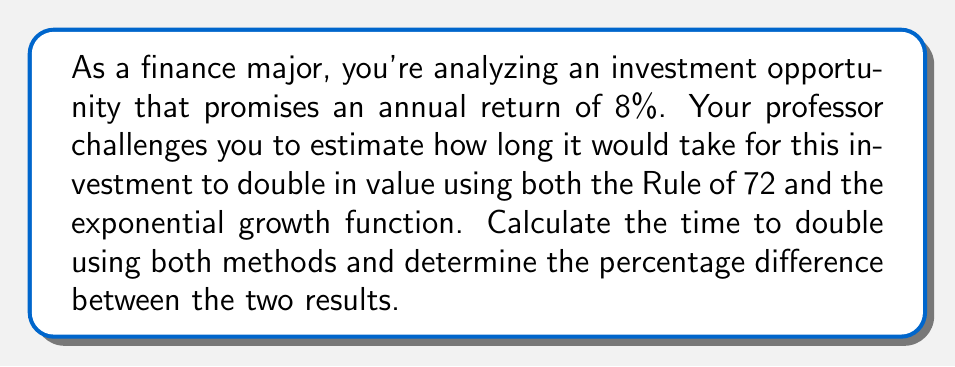Can you solve this math problem? Let's approach this problem step-by-step:

1. Using the Rule of 72:
   The Rule of 72 states that the time to double an investment is approximately:
   $$ T_{approx} = \frac{72}{r} $$
   where $r$ is the annual return rate as a percentage.

   For an 8% annual return:
   $$ T_{approx} = \frac{72}{8} = 9 \text{ years} $$

2. Using the exponential growth function:
   The exact time to double can be calculated using the formula:
   $$ 2 = (1 + r)^t $$
   where $r$ is the annual return rate as a decimal and $t$ is the time in years.

   Taking the natural log of both sides:
   $$ \ln(2) = t \cdot \ln(1 + 0.08) $$

   Solving for $t$:
   $$ t = \frac{\ln(2)}{\ln(1.08)} \approx 9.006 \text{ years} $$

3. Calculate the percentage difference:
   $$ \text{Percentage Difference} = \frac{|T_{exact} - T_{approx}|}{T_{exact}} \times 100\% $$
   $$ = \frac{|9.006 - 9|}{9.006} \times 100\% \approx 0.067\% $$

This small difference demonstrates the accuracy of the Rule of 72 for reasonable interest rates, making it a valuable tool for quick estimations in finance.
Answer: Time to double using Rule of 72: 9 years
Time to double using exponential function: 9.006 years
Percentage difference: 0.067% 